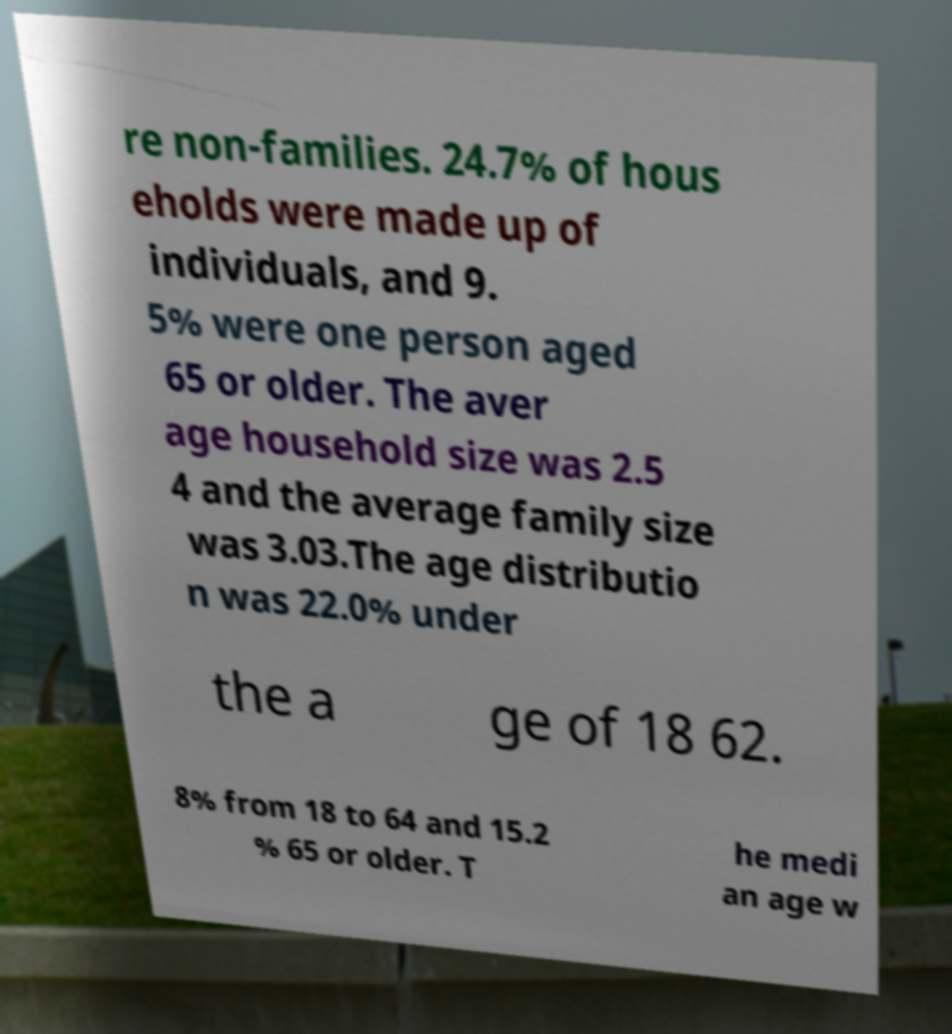Please identify and transcribe the text found in this image. re non-families. 24.7% of hous eholds were made up of individuals, and 9. 5% were one person aged 65 or older. The aver age household size was 2.5 4 and the average family size was 3.03.The age distributio n was 22.0% under the a ge of 18 62. 8% from 18 to 64 and 15.2 % 65 or older. T he medi an age w 